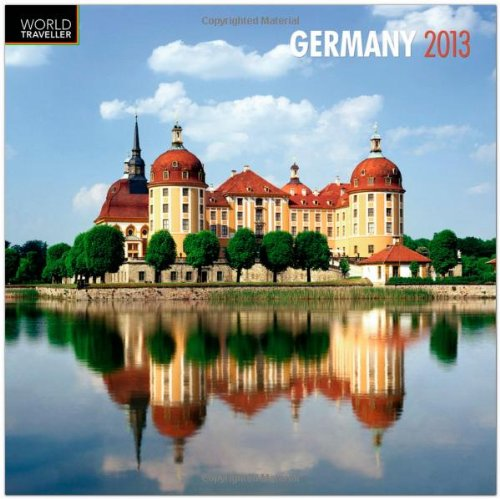Are there any notable locations or landmarks depicted in this calendar? While I cannot confirm the exact location without additional context, the calendar is focused on Germany and typically would feature important cultural, historical, or natural landmarks that are significant to the country. Could you describe one of these notable landmarks from Germany? One prominent German landmark is the Brandenburg Gate in Berlin, an 18th-century neoclassical monument that has become a symbol of unity and peace. 